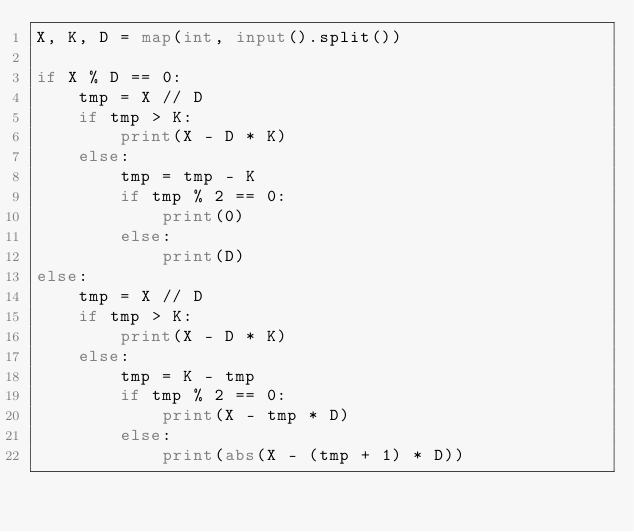<code> <loc_0><loc_0><loc_500><loc_500><_Python_>X, K, D = map(int, input().split())

if X % D == 0:
    tmp = X // D
    if tmp > K:
        print(X - D * K)
    else:
        tmp = tmp - K
        if tmp % 2 == 0:
            print(0)
        else:
            print(D)
else:
    tmp = X // D
    if tmp > K:
        print(X - D * K)
    else:
        tmp = K - tmp
        if tmp % 2 == 0:
            print(X - tmp * D)
        else:
            print(abs(X - (tmp + 1) * D))</code> 